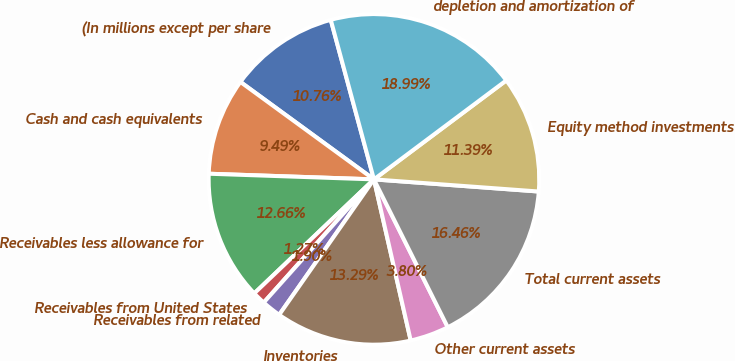<chart> <loc_0><loc_0><loc_500><loc_500><pie_chart><fcel>(In millions except per share<fcel>Cash and cash equivalents<fcel>Receivables less allowance for<fcel>Receivables from United States<fcel>Receivables from related<fcel>Inventories<fcel>Other current assets<fcel>Total current assets<fcel>Equity method investments<fcel>depletion and amortization of<nl><fcel>10.76%<fcel>9.49%<fcel>12.66%<fcel>1.27%<fcel>1.9%<fcel>13.29%<fcel>3.8%<fcel>16.46%<fcel>11.39%<fcel>18.99%<nl></chart> 